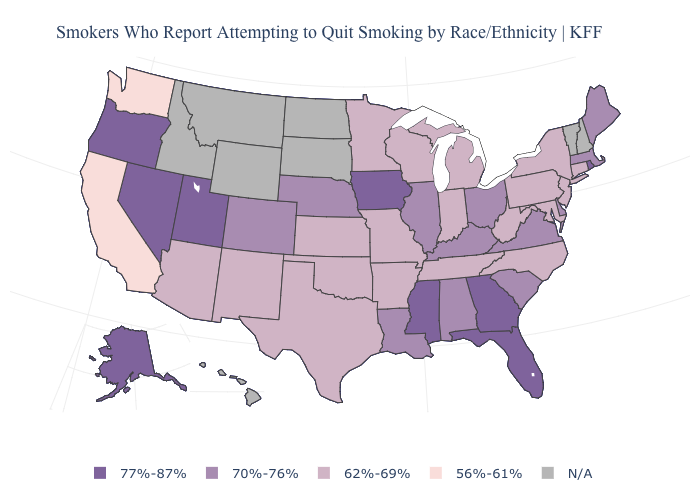What is the lowest value in the USA?
Give a very brief answer. 56%-61%. How many symbols are there in the legend?
Concise answer only. 5. Does the map have missing data?
Give a very brief answer. Yes. Name the states that have a value in the range 56%-61%?
Keep it brief. California, Washington. Among the states that border Wisconsin , does Iowa have the highest value?
Short answer required. Yes. What is the value of New York?
Concise answer only. 62%-69%. Name the states that have a value in the range 56%-61%?
Keep it brief. California, Washington. How many symbols are there in the legend?
Short answer required. 5. Name the states that have a value in the range 56%-61%?
Write a very short answer. California, Washington. Among the states that border South Carolina , which have the highest value?
Give a very brief answer. Georgia. What is the highest value in the Northeast ?
Short answer required. 77%-87%. Name the states that have a value in the range 62%-69%?
Concise answer only. Arizona, Arkansas, Connecticut, Indiana, Kansas, Maryland, Michigan, Minnesota, Missouri, New Jersey, New Mexico, New York, North Carolina, Oklahoma, Pennsylvania, Tennessee, Texas, West Virginia, Wisconsin. Which states have the lowest value in the MidWest?
Keep it brief. Indiana, Kansas, Michigan, Minnesota, Missouri, Wisconsin. Does New Jersey have the lowest value in the Northeast?
Quick response, please. Yes. 